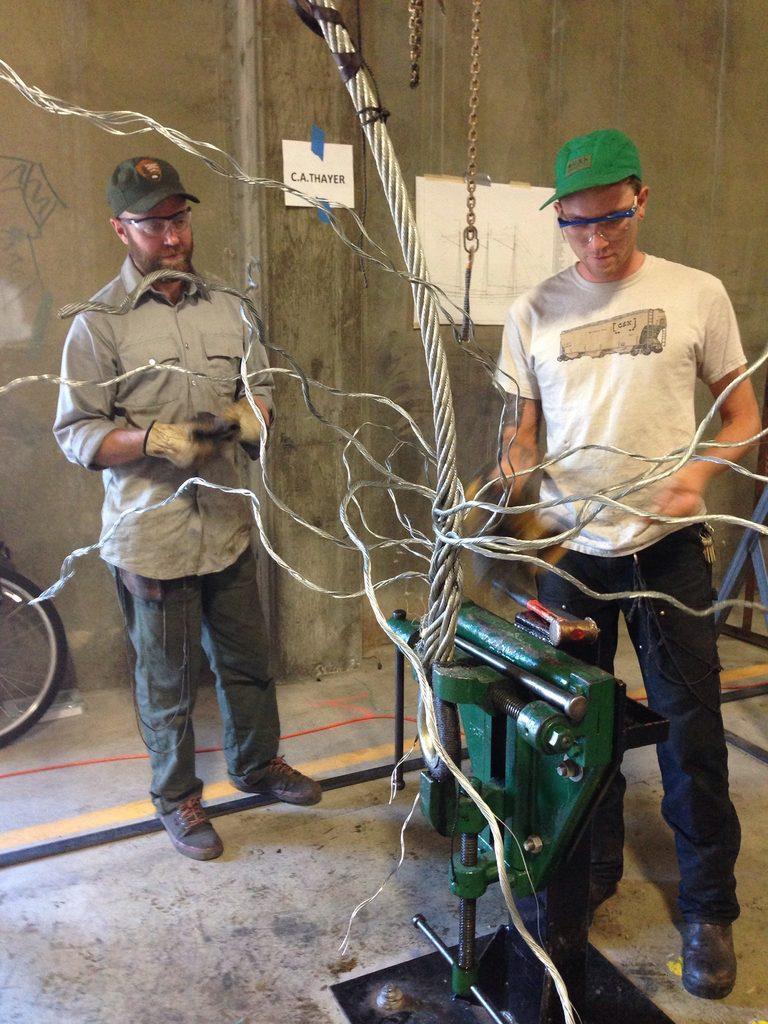How would you summarize this image in a sentence or two? In this image there are two people standing in front of them there is some machine connected with cables, behind them there is a wall. 